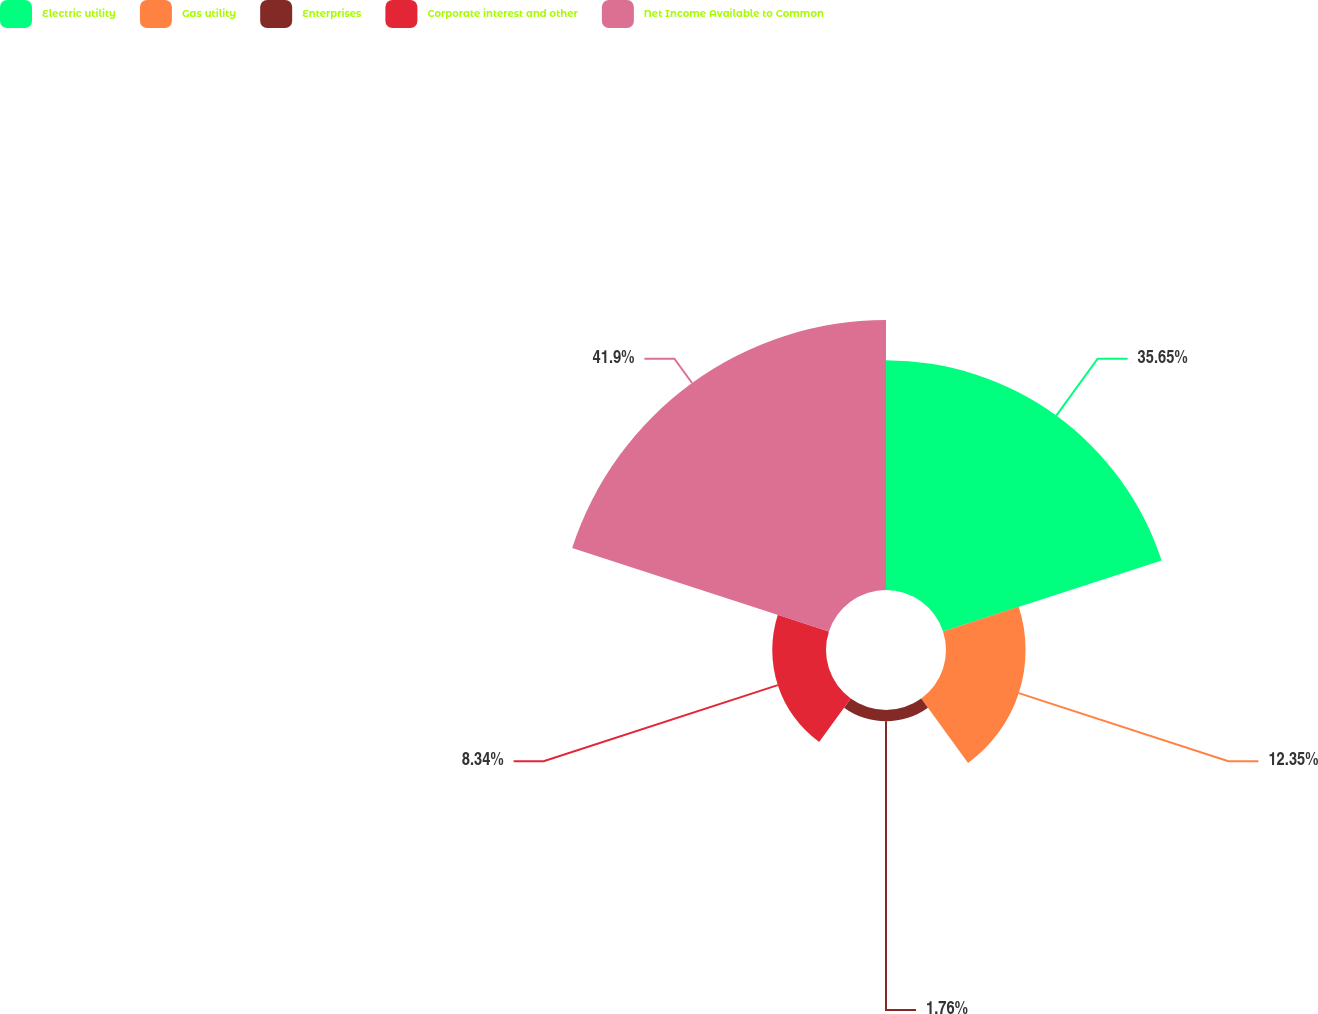<chart> <loc_0><loc_0><loc_500><loc_500><pie_chart><fcel>Electric utility<fcel>Gas utility<fcel>Enterprises<fcel>Corporate interest and other<fcel>Net Income Available to Common<nl><fcel>35.65%<fcel>12.35%<fcel>1.76%<fcel>8.34%<fcel>41.9%<nl></chart> 